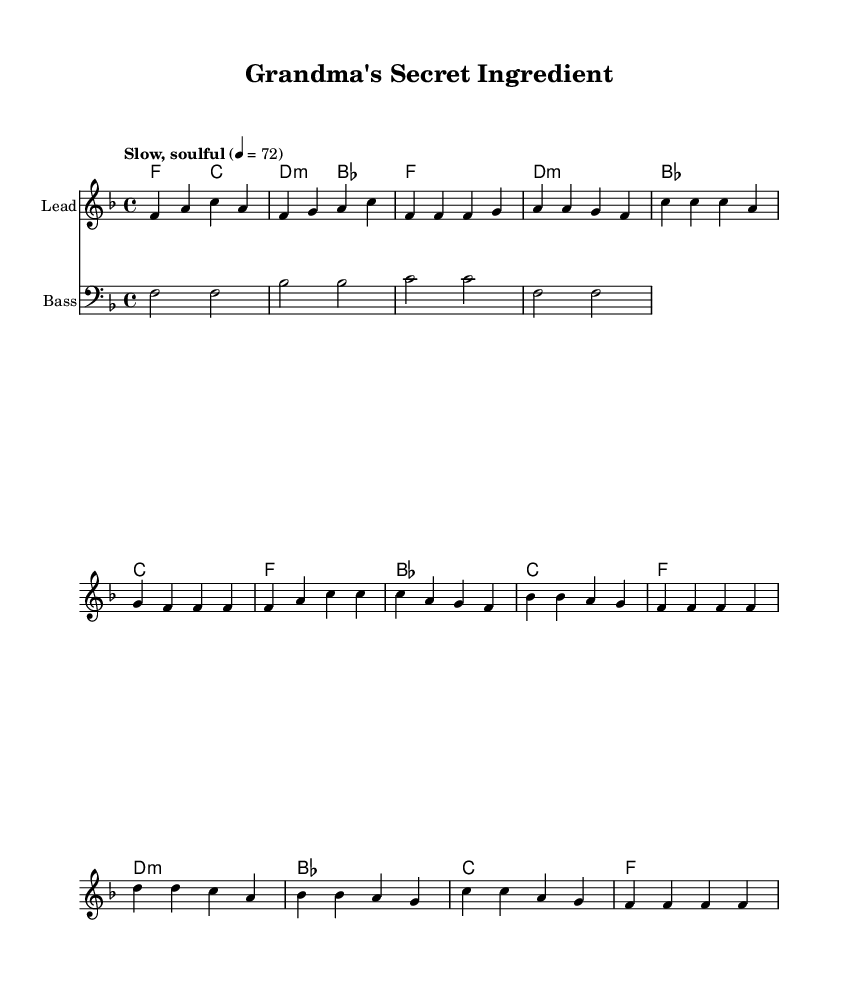What is the key signature of this music? The key signature is indicated at the beginning of the sheet music, showing one flat symbol, which corresponds to the key of F major.
Answer: F major What is the time signature of this music? The time signature, located at the beginning of the score, shows a 4 over 4, meaning there are four beats per measure and a quarter note gets one beat.
Answer: 4/4 What is the tempo marking for this piece? The tempo marking is written above the staff, specifying "Slow, soulful" with a metronome mark of 72 beats per minute, indicating the speed and feel of the music.
Answer: Slow, soulful Which section is the chorus? The chorus is recognized by its repeated musical phrases and distinct lyrical content, found after the first verse; it is marked at the beginning of the section with the corresponding lyrics.
Answer: Chorus How many measures are in the bridge section? The bridge section can be counted by examining the measures labeled under the musical notation. There are four measures in this bridge section of the song, providing a contrasting part of the music.
Answer: 4 What type of instrument is the lead staff for? The lead staff is noted at the top of the staff, indicating the specific instrument being played; in this case, it is simply labeled as "Lead."
Answer: Lead What genre does this music belong to? The genre of this music can be inferred from the title and style indicated at the beginning of the piece; it reflects the characteristics of Rhythm and Blues, especially through the soulful themes and melodic content.
Answer: Rhythm and Blues 